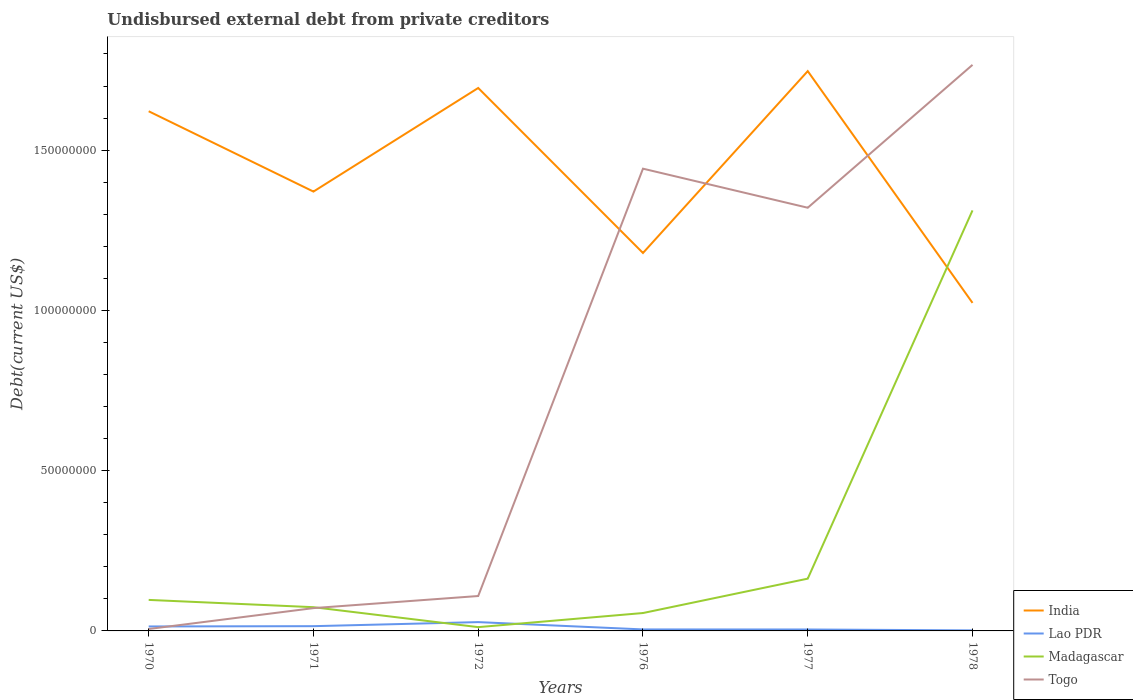How many different coloured lines are there?
Provide a short and direct response. 4. Does the line corresponding to India intersect with the line corresponding to Lao PDR?
Provide a succinct answer. No. Across all years, what is the maximum total debt in India?
Keep it short and to the point. 1.02e+08. In which year was the total debt in India maximum?
Make the answer very short. 1978. What is the total total debt in India in the graph?
Keep it short and to the point. 1.92e+07. What is the difference between the highest and the second highest total debt in Togo?
Ensure brevity in your answer.  1.76e+08. Is the total debt in Togo strictly greater than the total debt in Madagascar over the years?
Offer a terse response. No. How many lines are there?
Offer a terse response. 4. What is the difference between two consecutive major ticks on the Y-axis?
Your answer should be very brief. 5.00e+07. Are the values on the major ticks of Y-axis written in scientific E-notation?
Make the answer very short. No. Does the graph contain any zero values?
Offer a very short reply. No. How many legend labels are there?
Your response must be concise. 4. What is the title of the graph?
Your answer should be very brief. Undisbursed external debt from private creditors. Does "Croatia" appear as one of the legend labels in the graph?
Provide a succinct answer. No. What is the label or title of the Y-axis?
Make the answer very short. Debt(current US$). What is the Debt(current US$) in India in 1970?
Your response must be concise. 1.62e+08. What is the Debt(current US$) in Lao PDR in 1970?
Keep it short and to the point. 1.40e+06. What is the Debt(current US$) in Madagascar in 1970?
Ensure brevity in your answer.  9.67e+06. What is the Debt(current US$) of Togo in 1970?
Offer a very short reply. 6.00e+05. What is the Debt(current US$) of India in 1971?
Offer a very short reply. 1.37e+08. What is the Debt(current US$) in Lao PDR in 1971?
Provide a short and direct response. 1.48e+06. What is the Debt(current US$) of Madagascar in 1971?
Give a very brief answer. 7.40e+06. What is the Debt(current US$) in Togo in 1971?
Offer a terse response. 7.12e+06. What is the Debt(current US$) in India in 1972?
Make the answer very short. 1.69e+08. What is the Debt(current US$) in Lao PDR in 1972?
Offer a terse response. 2.75e+06. What is the Debt(current US$) of Madagascar in 1972?
Keep it short and to the point. 1.18e+06. What is the Debt(current US$) of Togo in 1972?
Give a very brief answer. 1.09e+07. What is the Debt(current US$) of India in 1976?
Your response must be concise. 1.18e+08. What is the Debt(current US$) of Lao PDR in 1976?
Your response must be concise. 4.68e+05. What is the Debt(current US$) in Madagascar in 1976?
Offer a very short reply. 5.58e+06. What is the Debt(current US$) of Togo in 1976?
Ensure brevity in your answer.  1.44e+08. What is the Debt(current US$) in India in 1977?
Offer a terse response. 1.75e+08. What is the Debt(current US$) of Lao PDR in 1977?
Keep it short and to the point. 4.46e+05. What is the Debt(current US$) of Madagascar in 1977?
Offer a terse response. 1.63e+07. What is the Debt(current US$) in Togo in 1977?
Make the answer very short. 1.32e+08. What is the Debt(current US$) in India in 1978?
Give a very brief answer. 1.02e+08. What is the Debt(current US$) in Lao PDR in 1978?
Make the answer very short. 1.69e+05. What is the Debt(current US$) of Madagascar in 1978?
Make the answer very short. 1.31e+08. What is the Debt(current US$) of Togo in 1978?
Keep it short and to the point. 1.77e+08. Across all years, what is the maximum Debt(current US$) in India?
Provide a short and direct response. 1.75e+08. Across all years, what is the maximum Debt(current US$) of Lao PDR?
Your response must be concise. 2.75e+06. Across all years, what is the maximum Debt(current US$) in Madagascar?
Give a very brief answer. 1.31e+08. Across all years, what is the maximum Debt(current US$) of Togo?
Your answer should be very brief. 1.77e+08. Across all years, what is the minimum Debt(current US$) of India?
Make the answer very short. 1.02e+08. Across all years, what is the minimum Debt(current US$) of Lao PDR?
Provide a succinct answer. 1.69e+05. Across all years, what is the minimum Debt(current US$) in Madagascar?
Give a very brief answer. 1.18e+06. Across all years, what is the minimum Debt(current US$) in Togo?
Give a very brief answer. 6.00e+05. What is the total Debt(current US$) of India in the graph?
Provide a short and direct response. 8.63e+08. What is the total Debt(current US$) in Lao PDR in the graph?
Provide a short and direct response. 6.71e+06. What is the total Debt(current US$) in Madagascar in the graph?
Provide a succinct answer. 1.71e+08. What is the total Debt(current US$) in Togo in the graph?
Your answer should be very brief. 4.71e+08. What is the difference between the Debt(current US$) of India in 1970 and that in 1971?
Your answer should be very brief. 2.51e+07. What is the difference between the Debt(current US$) in Lao PDR in 1970 and that in 1971?
Offer a terse response. -8.90e+04. What is the difference between the Debt(current US$) in Madagascar in 1970 and that in 1971?
Your answer should be very brief. 2.27e+06. What is the difference between the Debt(current US$) of Togo in 1970 and that in 1971?
Provide a short and direct response. -6.52e+06. What is the difference between the Debt(current US$) of India in 1970 and that in 1972?
Your answer should be very brief. -7.26e+06. What is the difference between the Debt(current US$) in Lao PDR in 1970 and that in 1972?
Offer a terse response. -1.35e+06. What is the difference between the Debt(current US$) of Madagascar in 1970 and that in 1972?
Your response must be concise. 8.49e+06. What is the difference between the Debt(current US$) in Togo in 1970 and that in 1972?
Make the answer very short. -1.03e+07. What is the difference between the Debt(current US$) of India in 1970 and that in 1976?
Ensure brevity in your answer.  4.42e+07. What is the difference between the Debt(current US$) of Lao PDR in 1970 and that in 1976?
Ensure brevity in your answer.  9.27e+05. What is the difference between the Debt(current US$) in Madagascar in 1970 and that in 1976?
Offer a terse response. 4.09e+06. What is the difference between the Debt(current US$) of Togo in 1970 and that in 1976?
Ensure brevity in your answer.  -1.44e+08. What is the difference between the Debt(current US$) in India in 1970 and that in 1977?
Ensure brevity in your answer.  -1.25e+07. What is the difference between the Debt(current US$) of Lao PDR in 1970 and that in 1977?
Provide a succinct answer. 9.49e+05. What is the difference between the Debt(current US$) of Madagascar in 1970 and that in 1977?
Offer a very short reply. -6.63e+06. What is the difference between the Debt(current US$) in Togo in 1970 and that in 1977?
Ensure brevity in your answer.  -1.31e+08. What is the difference between the Debt(current US$) in India in 1970 and that in 1978?
Provide a short and direct response. 5.98e+07. What is the difference between the Debt(current US$) in Lao PDR in 1970 and that in 1978?
Give a very brief answer. 1.23e+06. What is the difference between the Debt(current US$) of Madagascar in 1970 and that in 1978?
Provide a short and direct response. -1.22e+08. What is the difference between the Debt(current US$) of Togo in 1970 and that in 1978?
Your answer should be very brief. -1.76e+08. What is the difference between the Debt(current US$) of India in 1971 and that in 1972?
Keep it short and to the point. -3.23e+07. What is the difference between the Debt(current US$) in Lao PDR in 1971 and that in 1972?
Provide a short and direct response. -1.26e+06. What is the difference between the Debt(current US$) of Madagascar in 1971 and that in 1972?
Your answer should be very brief. 6.22e+06. What is the difference between the Debt(current US$) in Togo in 1971 and that in 1972?
Provide a succinct answer. -3.77e+06. What is the difference between the Debt(current US$) of India in 1971 and that in 1976?
Offer a terse response. 1.92e+07. What is the difference between the Debt(current US$) of Lao PDR in 1971 and that in 1976?
Make the answer very short. 1.02e+06. What is the difference between the Debt(current US$) of Madagascar in 1971 and that in 1976?
Your answer should be very brief. 1.82e+06. What is the difference between the Debt(current US$) of Togo in 1971 and that in 1976?
Your response must be concise. -1.37e+08. What is the difference between the Debt(current US$) of India in 1971 and that in 1977?
Keep it short and to the point. -3.76e+07. What is the difference between the Debt(current US$) in Lao PDR in 1971 and that in 1977?
Provide a succinct answer. 1.04e+06. What is the difference between the Debt(current US$) in Madagascar in 1971 and that in 1977?
Give a very brief answer. -8.90e+06. What is the difference between the Debt(current US$) in Togo in 1971 and that in 1977?
Your answer should be compact. -1.25e+08. What is the difference between the Debt(current US$) in India in 1971 and that in 1978?
Provide a short and direct response. 3.47e+07. What is the difference between the Debt(current US$) in Lao PDR in 1971 and that in 1978?
Offer a terse response. 1.32e+06. What is the difference between the Debt(current US$) in Madagascar in 1971 and that in 1978?
Your answer should be very brief. -1.24e+08. What is the difference between the Debt(current US$) in Togo in 1971 and that in 1978?
Ensure brevity in your answer.  -1.69e+08. What is the difference between the Debt(current US$) in India in 1972 and that in 1976?
Your answer should be very brief. 5.15e+07. What is the difference between the Debt(current US$) of Lao PDR in 1972 and that in 1976?
Offer a terse response. 2.28e+06. What is the difference between the Debt(current US$) in Madagascar in 1972 and that in 1976?
Provide a succinct answer. -4.40e+06. What is the difference between the Debt(current US$) of Togo in 1972 and that in 1976?
Provide a short and direct response. -1.33e+08. What is the difference between the Debt(current US$) in India in 1972 and that in 1977?
Your response must be concise. -5.25e+06. What is the difference between the Debt(current US$) in Lao PDR in 1972 and that in 1977?
Your response must be concise. 2.30e+06. What is the difference between the Debt(current US$) of Madagascar in 1972 and that in 1977?
Give a very brief answer. -1.51e+07. What is the difference between the Debt(current US$) of Togo in 1972 and that in 1977?
Make the answer very short. -1.21e+08. What is the difference between the Debt(current US$) of India in 1972 and that in 1978?
Provide a short and direct response. 6.70e+07. What is the difference between the Debt(current US$) of Lao PDR in 1972 and that in 1978?
Ensure brevity in your answer.  2.58e+06. What is the difference between the Debt(current US$) in Madagascar in 1972 and that in 1978?
Provide a short and direct response. -1.30e+08. What is the difference between the Debt(current US$) of Togo in 1972 and that in 1978?
Make the answer very short. -1.66e+08. What is the difference between the Debt(current US$) of India in 1976 and that in 1977?
Offer a very short reply. -5.67e+07. What is the difference between the Debt(current US$) in Lao PDR in 1976 and that in 1977?
Offer a very short reply. 2.20e+04. What is the difference between the Debt(current US$) of Madagascar in 1976 and that in 1977?
Ensure brevity in your answer.  -1.07e+07. What is the difference between the Debt(current US$) in Togo in 1976 and that in 1977?
Your answer should be compact. 1.22e+07. What is the difference between the Debt(current US$) in India in 1976 and that in 1978?
Keep it short and to the point. 1.56e+07. What is the difference between the Debt(current US$) in Lao PDR in 1976 and that in 1978?
Offer a very short reply. 2.99e+05. What is the difference between the Debt(current US$) in Madagascar in 1976 and that in 1978?
Offer a terse response. -1.26e+08. What is the difference between the Debt(current US$) of Togo in 1976 and that in 1978?
Your response must be concise. -3.24e+07. What is the difference between the Debt(current US$) of India in 1977 and that in 1978?
Provide a succinct answer. 7.23e+07. What is the difference between the Debt(current US$) in Lao PDR in 1977 and that in 1978?
Offer a very short reply. 2.77e+05. What is the difference between the Debt(current US$) of Madagascar in 1977 and that in 1978?
Your answer should be very brief. -1.15e+08. What is the difference between the Debt(current US$) in Togo in 1977 and that in 1978?
Provide a short and direct response. -4.46e+07. What is the difference between the Debt(current US$) in India in 1970 and the Debt(current US$) in Lao PDR in 1971?
Give a very brief answer. 1.61e+08. What is the difference between the Debt(current US$) in India in 1970 and the Debt(current US$) in Madagascar in 1971?
Keep it short and to the point. 1.55e+08. What is the difference between the Debt(current US$) of India in 1970 and the Debt(current US$) of Togo in 1971?
Provide a short and direct response. 1.55e+08. What is the difference between the Debt(current US$) in Lao PDR in 1970 and the Debt(current US$) in Madagascar in 1971?
Make the answer very short. -6.01e+06. What is the difference between the Debt(current US$) in Lao PDR in 1970 and the Debt(current US$) in Togo in 1971?
Give a very brief answer. -5.72e+06. What is the difference between the Debt(current US$) of Madagascar in 1970 and the Debt(current US$) of Togo in 1971?
Provide a short and direct response. 2.56e+06. What is the difference between the Debt(current US$) in India in 1970 and the Debt(current US$) in Lao PDR in 1972?
Your answer should be very brief. 1.59e+08. What is the difference between the Debt(current US$) of India in 1970 and the Debt(current US$) of Madagascar in 1972?
Ensure brevity in your answer.  1.61e+08. What is the difference between the Debt(current US$) of India in 1970 and the Debt(current US$) of Togo in 1972?
Give a very brief answer. 1.51e+08. What is the difference between the Debt(current US$) of Lao PDR in 1970 and the Debt(current US$) of Madagascar in 1972?
Provide a succinct answer. 2.12e+05. What is the difference between the Debt(current US$) of Lao PDR in 1970 and the Debt(current US$) of Togo in 1972?
Ensure brevity in your answer.  -9.50e+06. What is the difference between the Debt(current US$) in Madagascar in 1970 and the Debt(current US$) in Togo in 1972?
Ensure brevity in your answer.  -1.22e+06. What is the difference between the Debt(current US$) of India in 1970 and the Debt(current US$) of Lao PDR in 1976?
Your response must be concise. 1.62e+08. What is the difference between the Debt(current US$) of India in 1970 and the Debt(current US$) of Madagascar in 1976?
Provide a short and direct response. 1.57e+08. What is the difference between the Debt(current US$) in India in 1970 and the Debt(current US$) in Togo in 1976?
Provide a short and direct response. 1.79e+07. What is the difference between the Debt(current US$) in Lao PDR in 1970 and the Debt(current US$) in Madagascar in 1976?
Provide a short and direct response. -4.19e+06. What is the difference between the Debt(current US$) in Lao PDR in 1970 and the Debt(current US$) in Togo in 1976?
Make the answer very short. -1.43e+08. What is the difference between the Debt(current US$) of Madagascar in 1970 and the Debt(current US$) of Togo in 1976?
Your response must be concise. -1.35e+08. What is the difference between the Debt(current US$) in India in 1970 and the Debt(current US$) in Lao PDR in 1977?
Offer a very short reply. 1.62e+08. What is the difference between the Debt(current US$) in India in 1970 and the Debt(current US$) in Madagascar in 1977?
Make the answer very short. 1.46e+08. What is the difference between the Debt(current US$) in India in 1970 and the Debt(current US$) in Togo in 1977?
Provide a short and direct response. 3.01e+07. What is the difference between the Debt(current US$) in Lao PDR in 1970 and the Debt(current US$) in Madagascar in 1977?
Provide a short and direct response. -1.49e+07. What is the difference between the Debt(current US$) of Lao PDR in 1970 and the Debt(current US$) of Togo in 1977?
Give a very brief answer. -1.31e+08. What is the difference between the Debt(current US$) of Madagascar in 1970 and the Debt(current US$) of Togo in 1977?
Your answer should be compact. -1.22e+08. What is the difference between the Debt(current US$) in India in 1970 and the Debt(current US$) in Lao PDR in 1978?
Your answer should be compact. 1.62e+08. What is the difference between the Debt(current US$) of India in 1970 and the Debt(current US$) of Madagascar in 1978?
Provide a succinct answer. 3.09e+07. What is the difference between the Debt(current US$) of India in 1970 and the Debt(current US$) of Togo in 1978?
Provide a short and direct response. -1.45e+07. What is the difference between the Debt(current US$) in Lao PDR in 1970 and the Debt(current US$) in Madagascar in 1978?
Your response must be concise. -1.30e+08. What is the difference between the Debt(current US$) in Lao PDR in 1970 and the Debt(current US$) in Togo in 1978?
Offer a terse response. -1.75e+08. What is the difference between the Debt(current US$) in Madagascar in 1970 and the Debt(current US$) in Togo in 1978?
Make the answer very short. -1.67e+08. What is the difference between the Debt(current US$) in India in 1971 and the Debt(current US$) in Lao PDR in 1972?
Provide a succinct answer. 1.34e+08. What is the difference between the Debt(current US$) of India in 1971 and the Debt(current US$) of Madagascar in 1972?
Your response must be concise. 1.36e+08. What is the difference between the Debt(current US$) in India in 1971 and the Debt(current US$) in Togo in 1972?
Make the answer very short. 1.26e+08. What is the difference between the Debt(current US$) of Lao PDR in 1971 and the Debt(current US$) of Madagascar in 1972?
Ensure brevity in your answer.  3.01e+05. What is the difference between the Debt(current US$) of Lao PDR in 1971 and the Debt(current US$) of Togo in 1972?
Your answer should be very brief. -9.41e+06. What is the difference between the Debt(current US$) of Madagascar in 1971 and the Debt(current US$) of Togo in 1972?
Your answer should be compact. -3.49e+06. What is the difference between the Debt(current US$) in India in 1971 and the Debt(current US$) in Lao PDR in 1976?
Give a very brief answer. 1.37e+08. What is the difference between the Debt(current US$) of India in 1971 and the Debt(current US$) of Madagascar in 1976?
Ensure brevity in your answer.  1.31e+08. What is the difference between the Debt(current US$) of India in 1971 and the Debt(current US$) of Togo in 1976?
Make the answer very short. -7.15e+06. What is the difference between the Debt(current US$) of Lao PDR in 1971 and the Debt(current US$) of Madagascar in 1976?
Your answer should be very brief. -4.10e+06. What is the difference between the Debt(current US$) in Lao PDR in 1971 and the Debt(current US$) in Togo in 1976?
Give a very brief answer. -1.43e+08. What is the difference between the Debt(current US$) in Madagascar in 1971 and the Debt(current US$) in Togo in 1976?
Your answer should be very brief. -1.37e+08. What is the difference between the Debt(current US$) in India in 1971 and the Debt(current US$) in Lao PDR in 1977?
Give a very brief answer. 1.37e+08. What is the difference between the Debt(current US$) of India in 1971 and the Debt(current US$) of Madagascar in 1977?
Offer a very short reply. 1.21e+08. What is the difference between the Debt(current US$) in India in 1971 and the Debt(current US$) in Togo in 1977?
Your answer should be very brief. 5.04e+06. What is the difference between the Debt(current US$) of Lao PDR in 1971 and the Debt(current US$) of Madagascar in 1977?
Your answer should be very brief. -1.48e+07. What is the difference between the Debt(current US$) of Lao PDR in 1971 and the Debt(current US$) of Togo in 1977?
Provide a succinct answer. -1.31e+08. What is the difference between the Debt(current US$) in Madagascar in 1971 and the Debt(current US$) in Togo in 1977?
Offer a very short reply. -1.25e+08. What is the difference between the Debt(current US$) of India in 1971 and the Debt(current US$) of Lao PDR in 1978?
Your answer should be compact. 1.37e+08. What is the difference between the Debt(current US$) in India in 1971 and the Debt(current US$) in Madagascar in 1978?
Ensure brevity in your answer.  5.87e+06. What is the difference between the Debt(current US$) in India in 1971 and the Debt(current US$) in Togo in 1978?
Give a very brief answer. -3.95e+07. What is the difference between the Debt(current US$) of Lao PDR in 1971 and the Debt(current US$) of Madagascar in 1978?
Provide a succinct answer. -1.30e+08. What is the difference between the Debt(current US$) in Lao PDR in 1971 and the Debt(current US$) in Togo in 1978?
Give a very brief answer. -1.75e+08. What is the difference between the Debt(current US$) in Madagascar in 1971 and the Debt(current US$) in Togo in 1978?
Provide a succinct answer. -1.69e+08. What is the difference between the Debt(current US$) in India in 1972 and the Debt(current US$) in Lao PDR in 1976?
Your answer should be very brief. 1.69e+08. What is the difference between the Debt(current US$) of India in 1972 and the Debt(current US$) of Madagascar in 1976?
Ensure brevity in your answer.  1.64e+08. What is the difference between the Debt(current US$) in India in 1972 and the Debt(current US$) in Togo in 1976?
Make the answer very short. 2.52e+07. What is the difference between the Debt(current US$) in Lao PDR in 1972 and the Debt(current US$) in Madagascar in 1976?
Your answer should be very brief. -2.83e+06. What is the difference between the Debt(current US$) of Lao PDR in 1972 and the Debt(current US$) of Togo in 1976?
Give a very brief answer. -1.41e+08. What is the difference between the Debt(current US$) in Madagascar in 1972 and the Debt(current US$) in Togo in 1976?
Make the answer very short. -1.43e+08. What is the difference between the Debt(current US$) in India in 1972 and the Debt(current US$) in Lao PDR in 1977?
Provide a succinct answer. 1.69e+08. What is the difference between the Debt(current US$) in India in 1972 and the Debt(current US$) in Madagascar in 1977?
Provide a short and direct response. 1.53e+08. What is the difference between the Debt(current US$) of India in 1972 and the Debt(current US$) of Togo in 1977?
Give a very brief answer. 3.74e+07. What is the difference between the Debt(current US$) of Lao PDR in 1972 and the Debt(current US$) of Madagascar in 1977?
Your response must be concise. -1.36e+07. What is the difference between the Debt(current US$) in Lao PDR in 1972 and the Debt(current US$) in Togo in 1977?
Your response must be concise. -1.29e+08. What is the difference between the Debt(current US$) in Madagascar in 1972 and the Debt(current US$) in Togo in 1977?
Give a very brief answer. -1.31e+08. What is the difference between the Debt(current US$) of India in 1972 and the Debt(current US$) of Lao PDR in 1978?
Give a very brief answer. 1.69e+08. What is the difference between the Debt(current US$) in India in 1972 and the Debt(current US$) in Madagascar in 1978?
Ensure brevity in your answer.  3.82e+07. What is the difference between the Debt(current US$) of India in 1972 and the Debt(current US$) of Togo in 1978?
Your answer should be compact. -7.21e+06. What is the difference between the Debt(current US$) of Lao PDR in 1972 and the Debt(current US$) of Madagascar in 1978?
Make the answer very short. -1.28e+08. What is the difference between the Debt(current US$) in Lao PDR in 1972 and the Debt(current US$) in Togo in 1978?
Ensure brevity in your answer.  -1.74e+08. What is the difference between the Debt(current US$) of Madagascar in 1972 and the Debt(current US$) of Togo in 1978?
Your answer should be compact. -1.75e+08. What is the difference between the Debt(current US$) of India in 1976 and the Debt(current US$) of Lao PDR in 1977?
Provide a succinct answer. 1.17e+08. What is the difference between the Debt(current US$) in India in 1976 and the Debt(current US$) in Madagascar in 1977?
Offer a very short reply. 1.02e+08. What is the difference between the Debt(current US$) of India in 1976 and the Debt(current US$) of Togo in 1977?
Make the answer very short. -1.41e+07. What is the difference between the Debt(current US$) of Lao PDR in 1976 and the Debt(current US$) of Madagascar in 1977?
Offer a terse response. -1.58e+07. What is the difference between the Debt(current US$) in Lao PDR in 1976 and the Debt(current US$) in Togo in 1977?
Keep it short and to the point. -1.32e+08. What is the difference between the Debt(current US$) in Madagascar in 1976 and the Debt(current US$) in Togo in 1977?
Offer a terse response. -1.26e+08. What is the difference between the Debt(current US$) of India in 1976 and the Debt(current US$) of Lao PDR in 1978?
Your answer should be compact. 1.18e+08. What is the difference between the Debt(current US$) of India in 1976 and the Debt(current US$) of Madagascar in 1978?
Ensure brevity in your answer.  -1.33e+07. What is the difference between the Debt(current US$) in India in 1976 and the Debt(current US$) in Togo in 1978?
Your answer should be very brief. -5.87e+07. What is the difference between the Debt(current US$) in Lao PDR in 1976 and the Debt(current US$) in Madagascar in 1978?
Offer a terse response. -1.31e+08. What is the difference between the Debt(current US$) in Lao PDR in 1976 and the Debt(current US$) in Togo in 1978?
Keep it short and to the point. -1.76e+08. What is the difference between the Debt(current US$) in Madagascar in 1976 and the Debt(current US$) in Togo in 1978?
Provide a short and direct response. -1.71e+08. What is the difference between the Debt(current US$) in India in 1977 and the Debt(current US$) in Lao PDR in 1978?
Give a very brief answer. 1.74e+08. What is the difference between the Debt(current US$) of India in 1977 and the Debt(current US$) of Madagascar in 1978?
Offer a terse response. 4.34e+07. What is the difference between the Debt(current US$) in India in 1977 and the Debt(current US$) in Togo in 1978?
Provide a succinct answer. -1.96e+06. What is the difference between the Debt(current US$) in Lao PDR in 1977 and the Debt(current US$) in Madagascar in 1978?
Your answer should be compact. -1.31e+08. What is the difference between the Debt(current US$) in Lao PDR in 1977 and the Debt(current US$) in Togo in 1978?
Your answer should be compact. -1.76e+08. What is the difference between the Debt(current US$) of Madagascar in 1977 and the Debt(current US$) of Togo in 1978?
Keep it short and to the point. -1.60e+08. What is the average Debt(current US$) in India per year?
Make the answer very short. 1.44e+08. What is the average Debt(current US$) of Lao PDR per year?
Ensure brevity in your answer.  1.12e+06. What is the average Debt(current US$) of Madagascar per year?
Make the answer very short. 2.86e+07. What is the average Debt(current US$) in Togo per year?
Provide a succinct answer. 7.86e+07. In the year 1970, what is the difference between the Debt(current US$) in India and Debt(current US$) in Lao PDR?
Keep it short and to the point. 1.61e+08. In the year 1970, what is the difference between the Debt(current US$) of India and Debt(current US$) of Madagascar?
Keep it short and to the point. 1.52e+08. In the year 1970, what is the difference between the Debt(current US$) of India and Debt(current US$) of Togo?
Provide a short and direct response. 1.62e+08. In the year 1970, what is the difference between the Debt(current US$) in Lao PDR and Debt(current US$) in Madagascar?
Ensure brevity in your answer.  -8.28e+06. In the year 1970, what is the difference between the Debt(current US$) of Lao PDR and Debt(current US$) of Togo?
Provide a succinct answer. 7.95e+05. In the year 1970, what is the difference between the Debt(current US$) of Madagascar and Debt(current US$) of Togo?
Offer a terse response. 9.07e+06. In the year 1971, what is the difference between the Debt(current US$) of India and Debt(current US$) of Lao PDR?
Keep it short and to the point. 1.36e+08. In the year 1971, what is the difference between the Debt(current US$) in India and Debt(current US$) in Madagascar?
Your answer should be very brief. 1.30e+08. In the year 1971, what is the difference between the Debt(current US$) in India and Debt(current US$) in Togo?
Ensure brevity in your answer.  1.30e+08. In the year 1971, what is the difference between the Debt(current US$) in Lao PDR and Debt(current US$) in Madagascar?
Give a very brief answer. -5.92e+06. In the year 1971, what is the difference between the Debt(current US$) in Lao PDR and Debt(current US$) in Togo?
Offer a terse response. -5.63e+06. In the year 1971, what is the difference between the Debt(current US$) in Madagascar and Debt(current US$) in Togo?
Keep it short and to the point. 2.88e+05. In the year 1972, what is the difference between the Debt(current US$) in India and Debt(current US$) in Lao PDR?
Provide a succinct answer. 1.67e+08. In the year 1972, what is the difference between the Debt(current US$) in India and Debt(current US$) in Madagascar?
Give a very brief answer. 1.68e+08. In the year 1972, what is the difference between the Debt(current US$) in India and Debt(current US$) in Togo?
Provide a succinct answer. 1.58e+08. In the year 1972, what is the difference between the Debt(current US$) in Lao PDR and Debt(current US$) in Madagascar?
Offer a very short reply. 1.56e+06. In the year 1972, what is the difference between the Debt(current US$) in Lao PDR and Debt(current US$) in Togo?
Your answer should be very brief. -8.14e+06. In the year 1972, what is the difference between the Debt(current US$) in Madagascar and Debt(current US$) in Togo?
Make the answer very short. -9.71e+06. In the year 1976, what is the difference between the Debt(current US$) of India and Debt(current US$) of Lao PDR?
Give a very brief answer. 1.17e+08. In the year 1976, what is the difference between the Debt(current US$) in India and Debt(current US$) in Madagascar?
Make the answer very short. 1.12e+08. In the year 1976, what is the difference between the Debt(current US$) of India and Debt(current US$) of Togo?
Give a very brief answer. -2.63e+07. In the year 1976, what is the difference between the Debt(current US$) of Lao PDR and Debt(current US$) of Madagascar?
Keep it short and to the point. -5.11e+06. In the year 1976, what is the difference between the Debt(current US$) in Lao PDR and Debt(current US$) in Togo?
Provide a succinct answer. -1.44e+08. In the year 1976, what is the difference between the Debt(current US$) of Madagascar and Debt(current US$) of Togo?
Provide a succinct answer. -1.39e+08. In the year 1977, what is the difference between the Debt(current US$) of India and Debt(current US$) of Lao PDR?
Your response must be concise. 1.74e+08. In the year 1977, what is the difference between the Debt(current US$) in India and Debt(current US$) in Madagascar?
Your response must be concise. 1.58e+08. In the year 1977, what is the difference between the Debt(current US$) in India and Debt(current US$) in Togo?
Ensure brevity in your answer.  4.26e+07. In the year 1977, what is the difference between the Debt(current US$) in Lao PDR and Debt(current US$) in Madagascar?
Give a very brief answer. -1.59e+07. In the year 1977, what is the difference between the Debt(current US$) in Lao PDR and Debt(current US$) in Togo?
Keep it short and to the point. -1.32e+08. In the year 1977, what is the difference between the Debt(current US$) in Madagascar and Debt(current US$) in Togo?
Offer a terse response. -1.16e+08. In the year 1978, what is the difference between the Debt(current US$) in India and Debt(current US$) in Lao PDR?
Provide a succinct answer. 1.02e+08. In the year 1978, what is the difference between the Debt(current US$) in India and Debt(current US$) in Madagascar?
Give a very brief answer. -2.89e+07. In the year 1978, what is the difference between the Debt(current US$) in India and Debt(current US$) in Togo?
Make the answer very short. -7.43e+07. In the year 1978, what is the difference between the Debt(current US$) in Lao PDR and Debt(current US$) in Madagascar?
Provide a succinct answer. -1.31e+08. In the year 1978, what is the difference between the Debt(current US$) of Lao PDR and Debt(current US$) of Togo?
Keep it short and to the point. -1.76e+08. In the year 1978, what is the difference between the Debt(current US$) in Madagascar and Debt(current US$) in Togo?
Keep it short and to the point. -4.54e+07. What is the ratio of the Debt(current US$) of India in 1970 to that in 1971?
Your answer should be compact. 1.18. What is the ratio of the Debt(current US$) in Madagascar in 1970 to that in 1971?
Keep it short and to the point. 1.31. What is the ratio of the Debt(current US$) of Togo in 1970 to that in 1971?
Ensure brevity in your answer.  0.08. What is the ratio of the Debt(current US$) of India in 1970 to that in 1972?
Your answer should be very brief. 0.96. What is the ratio of the Debt(current US$) in Lao PDR in 1970 to that in 1972?
Ensure brevity in your answer.  0.51. What is the ratio of the Debt(current US$) of Madagascar in 1970 to that in 1972?
Your answer should be very brief. 8.18. What is the ratio of the Debt(current US$) in Togo in 1970 to that in 1972?
Give a very brief answer. 0.06. What is the ratio of the Debt(current US$) of India in 1970 to that in 1976?
Provide a succinct answer. 1.38. What is the ratio of the Debt(current US$) of Lao PDR in 1970 to that in 1976?
Your answer should be very brief. 2.98. What is the ratio of the Debt(current US$) of Madagascar in 1970 to that in 1976?
Your response must be concise. 1.73. What is the ratio of the Debt(current US$) in Togo in 1970 to that in 1976?
Provide a succinct answer. 0. What is the ratio of the Debt(current US$) in India in 1970 to that in 1977?
Your answer should be very brief. 0.93. What is the ratio of the Debt(current US$) of Lao PDR in 1970 to that in 1977?
Offer a very short reply. 3.13. What is the ratio of the Debt(current US$) in Madagascar in 1970 to that in 1977?
Give a very brief answer. 0.59. What is the ratio of the Debt(current US$) in Togo in 1970 to that in 1977?
Offer a terse response. 0. What is the ratio of the Debt(current US$) of India in 1970 to that in 1978?
Provide a succinct answer. 1.58. What is the ratio of the Debt(current US$) of Lao PDR in 1970 to that in 1978?
Your answer should be very brief. 8.25. What is the ratio of the Debt(current US$) of Madagascar in 1970 to that in 1978?
Ensure brevity in your answer.  0.07. What is the ratio of the Debt(current US$) in Togo in 1970 to that in 1978?
Make the answer very short. 0. What is the ratio of the Debt(current US$) in India in 1971 to that in 1972?
Your answer should be very brief. 0.81. What is the ratio of the Debt(current US$) in Lao PDR in 1971 to that in 1972?
Provide a succinct answer. 0.54. What is the ratio of the Debt(current US$) in Madagascar in 1971 to that in 1972?
Ensure brevity in your answer.  6.26. What is the ratio of the Debt(current US$) of Togo in 1971 to that in 1972?
Provide a short and direct response. 0.65. What is the ratio of the Debt(current US$) of India in 1971 to that in 1976?
Offer a very short reply. 1.16. What is the ratio of the Debt(current US$) in Lao PDR in 1971 to that in 1976?
Your answer should be very brief. 3.17. What is the ratio of the Debt(current US$) of Madagascar in 1971 to that in 1976?
Your response must be concise. 1.33. What is the ratio of the Debt(current US$) in Togo in 1971 to that in 1976?
Give a very brief answer. 0.05. What is the ratio of the Debt(current US$) of India in 1971 to that in 1977?
Offer a terse response. 0.78. What is the ratio of the Debt(current US$) of Lao PDR in 1971 to that in 1977?
Provide a succinct answer. 3.33. What is the ratio of the Debt(current US$) of Madagascar in 1971 to that in 1977?
Your answer should be compact. 0.45. What is the ratio of the Debt(current US$) in Togo in 1971 to that in 1977?
Keep it short and to the point. 0.05. What is the ratio of the Debt(current US$) in India in 1971 to that in 1978?
Keep it short and to the point. 1.34. What is the ratio of the Debt(current US$) in Lao PDR in 1971 to that in 1978?
Your answer should be compact. 8.78. What is the ratio of the Debt(current US$) of Madagascar in 1971 to that in 1978?
Provide a succinct answer. 0.06. What is the ratio of the Debt(current US$) of Togo in 1971 to that in 1978?
Your answer should be very brief. 0.04. What is the ratio of the Debt(current US$) in India in 1972 to that in 1976?
Keep it short and to the point. 1.44. What is the ratio of the Debt(current US$) of Lao PDR in 1972 to that in 1976?
Make the answer very short. 5.87. What is the ratio of the Debt(current US$) of Madagascar in 1972 to that in 1976?
Provide a short and direct response. 0.21. What is the ratio of the Debt(current US$) in Togo in 1972 to that in 1976?
Your answer should be compact. 0.08. What is the ratio of the Debt(current US$) in India in 1972 to that in 1977?
Keep it short and to the point. 0.97. What is the ratio of the Debt(current US$) in Lao PDR in 1972 to that in 1977?
Ensure brevity in your answer.  6.16. What is the ratio of the Debt(current US$) of Madagascar in 1972 to that in 1977?
Keep it short and to the point. 0.07. What is the ratio of the Debt(current US$) in Togo in 1972 to that in 1977?
Your answer should be very brief. 0.08. What is the ratio of the Debt(current US$) of India in 1972 to that in 1978?
Your response must be concise. 1.66. What is the ratio of the Debt(current US$) in Lao PDR in 1972 to that in 1978?
Keep it short and to the point. 16.25. What is the ratio of the Debt(current US$) of Madagascar in 1972 to that in 1978?
Keep it short and to the point. 0.01. What is the ratio of the Debt(current US$) of Togo in 1972 to that in 1978?
Give a very brief answer. 0.06. What is the ratio of the Debt(current US$) of India in 1976 to that in 1977?
Provide a succinct answer. 0.68. What is the ratio of the Debt(current US$) in Lao PDR in 1976 to that in 1977?
Ensure brevity in your answer.  1.05. What is the ratio of the Debt(current US$) of Madagascar in 1976 to that in 1977?
Provide a short and direct response. 0.34. What is the ratio of the Debt(current US$) of Togo in 1976 to that in 1977?
Provide a succinct answer. 1.09. What is the ratio of the Debt(current US$) of India in 1976 to that in 1978?
Keep it short and to the point. 1.15. What is the ratio of the Debt(current US$) of Lao PDR in 1976 to that in 1978?
Offer a very short reply. 2.77. What is the ratio of the Debt(current US$) of Madagascar in 1976 to that in 1978?
Provide a succinct answer. 0.04. What is the ratio of the Debt(current US$) in Togo in 1976 to that in 1978?
Give a very brief answer. 0.82. What is the ratio of the Debt(current US$) in India in 1977 to that in 1978?
Your response must be concise. 1.71. What is the ratio of the Debt(current US$) of Lao PDR in 1977 to that in 1978?
Offer a very short reply. 2.64. What is the ratio of the Debt(current US$) of Madagascar in 1977 to that in 1978?
Your response must be concise. 0.12. What is the ratio of the Debt(current US$) of Togo in 1977 to that in 1978?
Offer a terse response. 0.75. What is the difference between the highest and the second highest Debt(current US$) in India?
Your response must be concise. 5.25e+06. What is the difference between the highest and the second highest Debt(current US$) of Lao PDR?
Your answer should be compact. 1.26e+06. What is the difference between the highest and the second highest Debt(current US$) of Madagascar?
Ensure brevity in your answer.  1.15e+08. What is the difference between the highest and the second highest Debt(current US$) of Togo?
Provide a succinct answer. 3.24e+07. What is the difference between the highest and the lowest Debt(current US$) in India?
Provide a short and direct response. 7.23e+07. What is the difference between the highest and the lowest Debt(current US$) in Lao PDR?
Your answer should be compact. 2.58e+06. What is the difference between the highest and the lowest Debt(current US$) of Madagascar?
Your answer should be very brief. 1.30e+08. What is the difference between the highest and the lowest Debt(current US$) in Togo?
Your answer should be compact. 1.76e+08. 